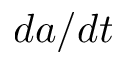Convert formula to latex. <formula><loc_0><loc_0><loc_500><loc_500>d a / d t</formula> 